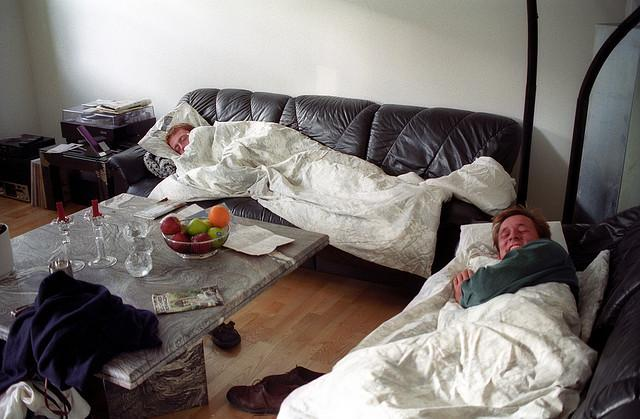What is the bowl holding the fruit made from? glass 